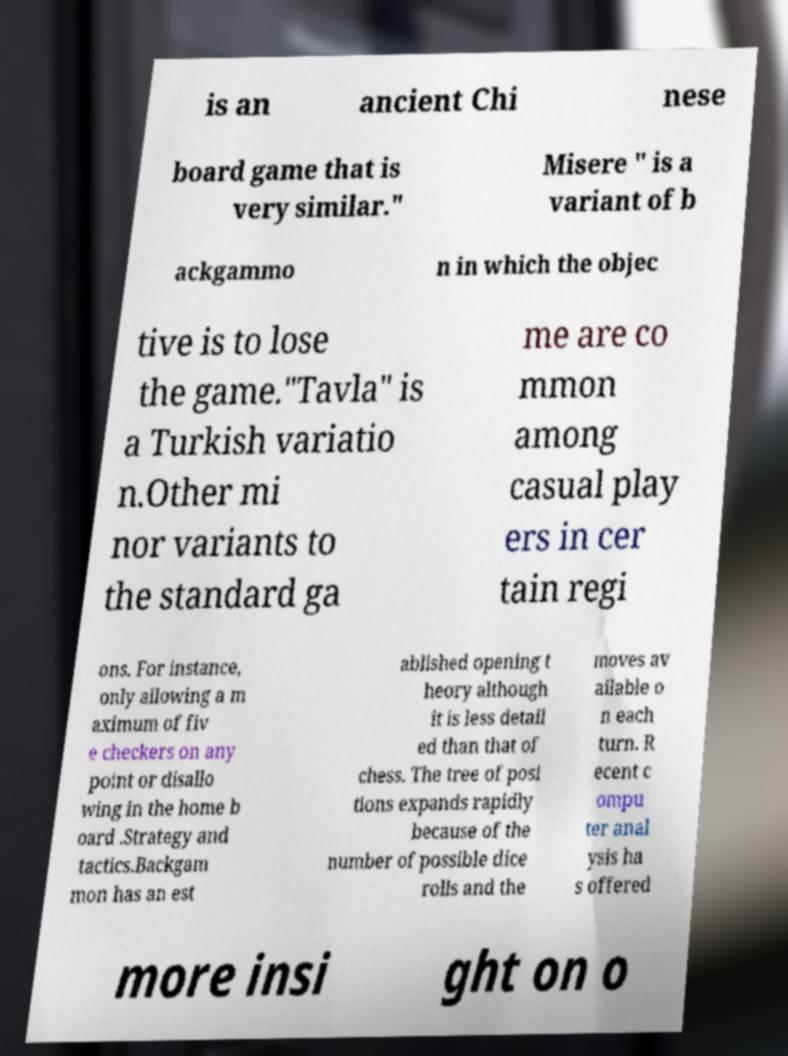Can you read and provide the text displayed in the image?This photo seems to have some interesting text. Can you extract and type it out for me? is an ancient Chi nese board game that is very similar." Misere " is a variant of b ackgammo n in which the objec tive is to lose the game."Tavla" is a Turkish variatio n.Other mi nor variants to the standard ga me are co mmon among casual play ers in cer tain regi ons. For instance, only allowing a m aximum of fiv e checkers on any point or disallo wing in the home b oard .Strategy and tactics.Backgam mon has an est ablished opening t heory although it is less detail ed than that of chess. The tree of posi tions expands rapidly because of the number of possible dice rolls and the moves av ailable o n each turn. R ecent c ompu ter anal ysis ha s offered more insi ght on o 